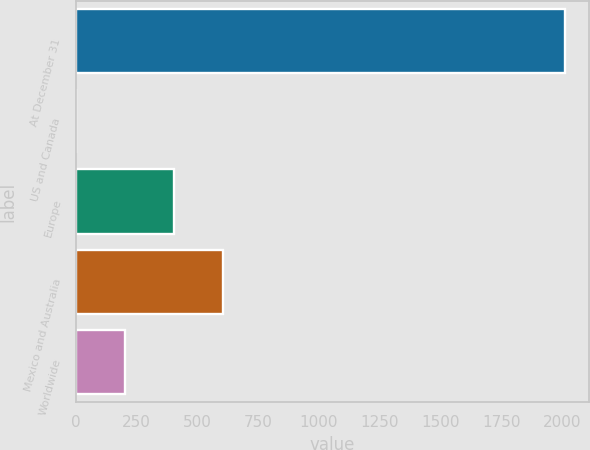Convert chart to OTSL. <chart><loc_0><loc_0><loc_500><loc_500><bar_chart><fcel>At December 31<fcel>US and Canada<fcel>Europe<fcel>Mexico and Australia<fcel>Worldwide<nl><fcel>2012<fcel>0.4<fcel>402.72<fcel>603.88<fcel>201.56<nl></chart> 